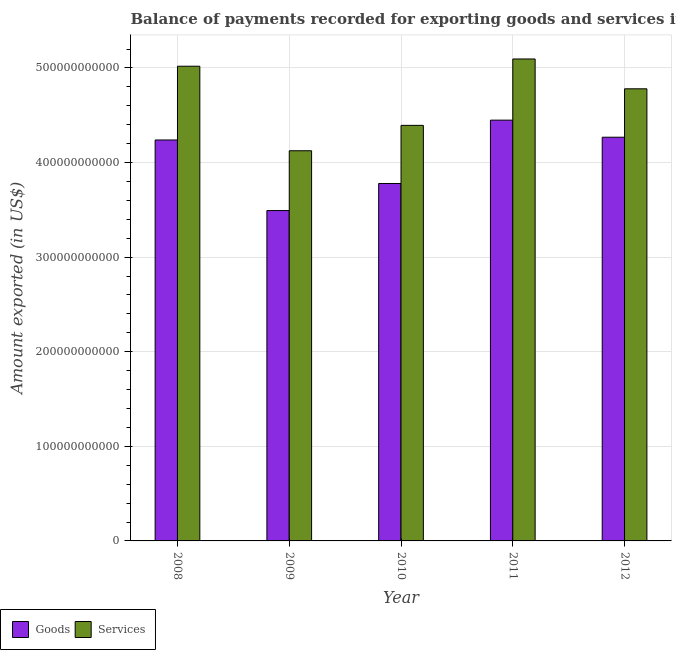Are the number of bars on each tick of the X-axis equal?
Keep it short and to the point. Yes. How many bars are there on the 2nd tick from the right?
Offer a very short reply. 2. What is the amount of services exported in 2012?
Your response must be concise. 4.78e+11. Across all years, what is the maximum amount of goods exported?
Give a very brief answer. 4.45e+11. Across all years, what is the minimum amount of services exported?
Your response must be concise. 4.12e+11. In which year was the amount of services exported maximum?
Your answer should be compact. 2011. In which year was the amount of services exported minimum?
Give a very brief answer. 2009. What is the total amount of services exported in the graph?
Your response must be concise. 2.34e+12. What is the difference between the amount of goods exported in 2009 and that in 2011?
Your response must be concise. -9.56e+1. What is the difference between the amount of services exported in 2011 and the amount of goods exported in 2009?
Your response must be concise. 9.70e+1. What is the average amount of goods exported per year?
Give a very brief answer. 4.05e+11. In how many years, is the amount of goods exported greater than 380000000000 US$?
Your response must be concise. 3. What is the ratio of the amount of goods exported in 2011 to that in 2012?
Ensure brevity in your answer.  1.04. Is the amount of services exported in 2008 less than that in 2010?
Your answer should be very brief. No. Is the difference between the amount of services exported in 2009 and 2012 greater than the difference between the amount of goods exported in 2009 and 2012?
Your answer should be compact. No. What is the difference between the highest and the second highest amount of goods exported?
Keep it short and to the point. 1.80e+1. What is the difference between the highest and the lowest amount of services exported?
Give a very brief answer. 9.70e+1. In how many years, is the amount of services exported greater than the average amount of services exported taken over all years?
Provide a succinct answer. 3. What does the 1st bar from the left in 2010 represents?
Keep it short and to the point. Goods. What does the 2nd bar from the right in 2011 represents?
Provide a short and direct response. Goods. How many bars are there?
Provide a short and direct response. 10. How many years are there in the graph?
Ensure brevity in your answer.  5. What is the difference between two consecutive major ticks on the Y-axis?
Offer a very short reply. 1.00e+11. Does the graph contain any zero values?
Give a very brief answer. No. Where does the legend appear in the graph?
Offer a terse response. Bottom left. How many legend labels are there?
Your response must be concise. 2. What is the title of the graph?
Offer a very short reply. Balance of payments recorded for exporting goods and services in Spain. Does "By country of origin" appear as one of the legend labels in the graph?
Offer a terse response. No. What is the label or title of the X-axis?
Your response must be concise. Year. What is the label or title of the Y-axis?
Your answer should be compact. Amount exported (in US$). What is the Amount exported (in US$) in Goods in 2008?
Your response must be concise. 4.24e+11. What is the Amount exported (in US$) in Services in 2008?
Offer a terse response. 5.02e+11. What is the Amount exported (in US$) of Goods in 2009?
Give a very brief answer. 3.49e+11. What is the Amount exported (in US$) in Services in 2009?
Offer a terse response. 4.12e+11. What is the Amount exported (in US$) in Goods in 2010?
Keep it short and to the point. 3.78e+11. What is the Amount exported (in US$) of Services in 2010?
Make the answer very short. 4.39e+11. What is the Amount exported (in US$) of Goods in 2011?
Ensure brevity in your answer.  4.45e+11. What is the Amount exported (in US$) in Services in 2011?
Your answer should be compact. 5.09e+11. What is the Amount exported (in US$) in Goods in 2012?
Provide a succinct answer. 4.27e+11. What is the Amount exported (in US$) in Services in 2012?
Your answer should be very brief. 4.78e+11. Across all years, what is the maximum Amount exported (in US$) of Goods?
Offer a terse response. 4.45e+11. Across all years, what is the maximum Amount exported (in US$) in Services?
Offer a terse response. 5.09e+11. Across all years, what is the minimum Amount exported (in US$) in Goods?
Make the answer very short. 3.49e+11. Across all years, what is the minimum Amount exported (in US$) of Services?
Your answer should be compact. 4.12e+11. What is the total Amount exported (in US$) of Goods in the graph?
Provide a succinct answer. 2.02e+12. What is the total Amount exported (in US$) of Services in the graph?
Your answer should be very brief. 2.34e+12. What is the difference between the Amount exported (in US$) in Goods in 2008 and that in 2009?
Provide a short and direct response. 7.46e+1. What is the difference between the Amount exported (in US$) in Services in 2008 and that in 2009?
Offer a terse response. 8.94e+1. What is the difference between the Amount exported (in US$) of Goods in 2008 and that in 2010?
Give a very brief answer. 4.60e+1. What is the difference between the Amount exported (in US$) in Services in 2008 and that in 2010?
Your answer should be compact. 6.25e+1. What is the difference between the Amount exported (in US$) of Goods in 2008 and that in 2011?
Keep it short and to the point. -2.10e+1. What is the difference between the Amount exported (in US$) of Services in 2008 and that in 2011?
Give a very brief answer. -7.68e+09. What is the difference between the Amount exported (in US$) in Goods in 2008 and that in 2012?
Make the answer very short. -2.91e+09. What is the difference between the Amount exported (in US$) of Services in 2008 and that in 2012?
Give a very brief answer. 2.39e+1. What is the difference between the Amount exported (in US$) in Goods in 2009 and that in 2010?
Offer a terse response. -2.86e+1. What is the difference between the Amount exported (in US$) of Services in 2009 and that in 2010?
Provide a succinct answer. -2.69e+1. What is the difference between the Amount exported (in US$) of Goods in 2009 and that in 2011?
Offer a terse response. -9.56e+1. What is the difference between the Amount exported (in US$) of Services in 2009 and that in 2011?
Provide a short and direct response. -9.70e+1. What is the difference between the Amount exported (in US$) in Goods in 2009 and that in 2012?
Provide a succinct answer. -7.75e+1. What is the difference between the Amount exported (in US$) of Services in 2009 and that in 2012?
Keep it short and to the point. -6.55e+1. What is the difference between the Amount exported (in US$) of Goods in 2010 and that in 2011?
Make the answer very short. -6.70e+1. What is the difference between the Amount exported (in US$) in Services in 2010 and that in 2011?
Your answer should be compact. -7.02e+1. What is the difference between the Amount exported (in US$) in Goods in 2010 and that in 2012?
Provide a short and direct response. -4.89e+1. What is the difference between the Amount exported (in US$) of Services in 2010 and that in 2012?
Offer a very short reply. -3.86e+1. What is the difference between the Amount exported (in US$) of Goods in 2011 and that in 2012?
Keep it short and to the point. 1.80e+1. What is the difference between the Amount exported (in US$) of Services in 2011 and that in 2012?
Your answer should be compact. 3.15e+1. What is the difference between the Amount exported (in US$) of Goods in 2008 and the Amount exported (in US$) of Services in 2009?
Ensure brevity in your answer.  1.14e+1. What is the difference between the Amount exported (in US$) of Goods in 2008 and the Amount exported (in US$) of Services in 2010?
Keep it short and to the point. -1.54e+1. What is the difference between the Amount exported (in US$) in Goods in 2008 and the Amount exported (in US$) in Services in 2011?
Provide a short and direct response. -8.56e+1. What is the difference between the Amount exported (in US$) in Goods in 2008 and the Amount exported (in US$) in Services in 2012?
Keep it short and to the point. -5.41e+1. What is the difference between the Amount exported (in US$) of Goods in 2009 and the Amount exported (in US$) of Services in 2010?
Make the answer very short. -9.01e+1. What is the difference between the Amount exported (in US$) in Goods in 2009 and the Amount exported (in US$) in Services in 2011?
Your answer should be very brief. -1.60e+11. What is the difference between the Amount exported (in US$) in Goods in 2009 and the Amount exported (in US$) in Services in 2012?
Your response must be concise. -1.29e+11. What is the difference between the Amount exported (in US$) of Goods in 2010 and the Amount exported (in US$) of Services in 2011?
Give a very brief answer. -1.32e+11. What is the difference between the Amount exported (in US$) in Goods in 2010 and the Amount exported (in US$) in Services in 2012?
Your answer should be very brief. -1.00e+11. What is the difference between the Amount exported (in US$) of Goods in 2011 and the Amount exported (in US$) of Services in 2012?
Your answer should be very brief. -3.31e+1. What is the average Amount exported (in US$) in Goods per year?
Your answer should be very brief. 4.05e+11. What is the average Amount exported (in US$) in Services per year?
Provide a short and direct response. 4.68e+11. In the year 2008, what is the difference between the Amount exported (in US$) of Goods and Amount exported (in US$) of Services?
Offer a terse response. -7.80e+1. In the year 2009, what is the difference between the Amount exported (in US$) in Goods and Amount exported (in US$) in Services?
Ensure brevity in your answer.  -6.32e+1. In the year 2010, what is the difference between the Amount exported (in US$) of Goods and Amount exported (in US$) of Services?
Offer a terse response. -6.15e+1. In the year 2011, what is the difference between the Amount exported (in US$) of Goods and Amount exported (in US$) of Services?
Ensure brevity in your answer.  -6.47e+1. In the year 2012, what is the difference between the Amount exported (in US$) in Goods and Amount exported (in US$) in Services?
Give a very brief answer. -5.12e+1. What is the ratio of the Amount exported (in US$) of Goods in 2008 to that in 2009?
Give a very brief answer. 1.21. What is the ratio of the Amount exported (in US$) of Services in 2008 to that in 2009?
Provide a succinct answer. 1.22. What is the ratio of the Amount exported (in US$) in Goods in 2008 to that in 2010?
Your answer should be compact. 1.12. What is the ratio of the Amount exported (in US$) of Services in 2008 to that in 2010?
Offer a very short reply. 1.14. What is the ratio of the Amount exported (in US$) in Goods in 2008 to that in 2011?
Make the answer very short. 0.95. What is the ratio of the Amount exported (in US$) in Services in 2008 to that in 2011?
Your answer should be very brief. 0.98. What is the ratio of the Amount exported (in US$) of Services in 2008 to that in 2012?
Provide a succinct answer. 1.05. What is the ratio of the Amount exported (in US$) in Goods in 2009 to that in 2010?
Your response must be concise. 0.92. What is the ratio of the Amount exported (in US$) of Services in 2009 to that in 2010?
Give a very brief answer. 0.94. What is the ratio of the Amount exported (in US$) of Goods in 2009 to that in 2011?
Give a very brief answer. 0.79. What is the ratio of the Amount exported (in US$) of Services in 2009 to that in 2011?
Ensure brevity in your answer.  0.81. What is the ratio of the Amount exported (in US$) of Goods in 2009 to that in 2012?
Make the answer very short. 0.82. What is the ratio of the Amount exported (in US$) of Services in 2009 to that in 2012?
Your answer should be very brief. 0.86. What is the ratio of the Amount exported (in US$) in Goods in 2010 to that in 2011?
Provide a short and direct response. 0.85. What is the ratio of the Amount exported (in US$) in Services in 2010 to that in 2011?
Your response must be concise. 0.86. What is the ratio of the Amount exported (in US$) of Goods in 2010 to that in 2012?
Give a very brief answer. 0.89. What is the ratio of the Amount exported (in US$) in Services in 2010 to that in 2012?
Make the answer very short. 0.92. What is the ratio of the Amount exported (in US$) in Goods in 2011 to that in 2012?
Your answer should be very brief. 1.04. What is the ratio of the Amount exported (in US$) in Services in 2011 to that in 2012?
Provide a short and direct response. 1.07. What is the difference between the highest and the second highest Amount exported (in US$) in Goods?
Your response must be concise. 1.80e+1. What is the difference between the highest and the second highest Amount exported (in US$) of Services?
Your answer should be compact. 7.68e+09. What is the difference between the highest and the lowest Amount exported (in US$) of Goods?
Your response must be concise. 9.56e+1. What is the difference between the highest and the lowest Amount exported (in US$) of Services?
Offer a very short reply. 9.70e+1. 